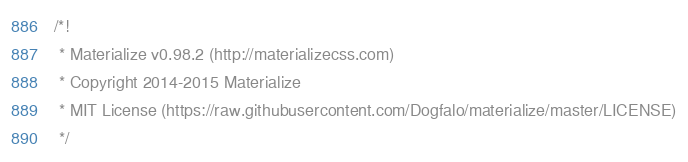<code> <loc_0><loc_0><loc_500><loc_500><_CSS_>/*!
 * Materialize v0.98.2 (http://materializecss.com)
 * Copyright 2014-2015 Materialize
 * MIT License (https://raw.githubusercontent.com/Dogfalo/materialize/master/LICENSE)
 */</code> 